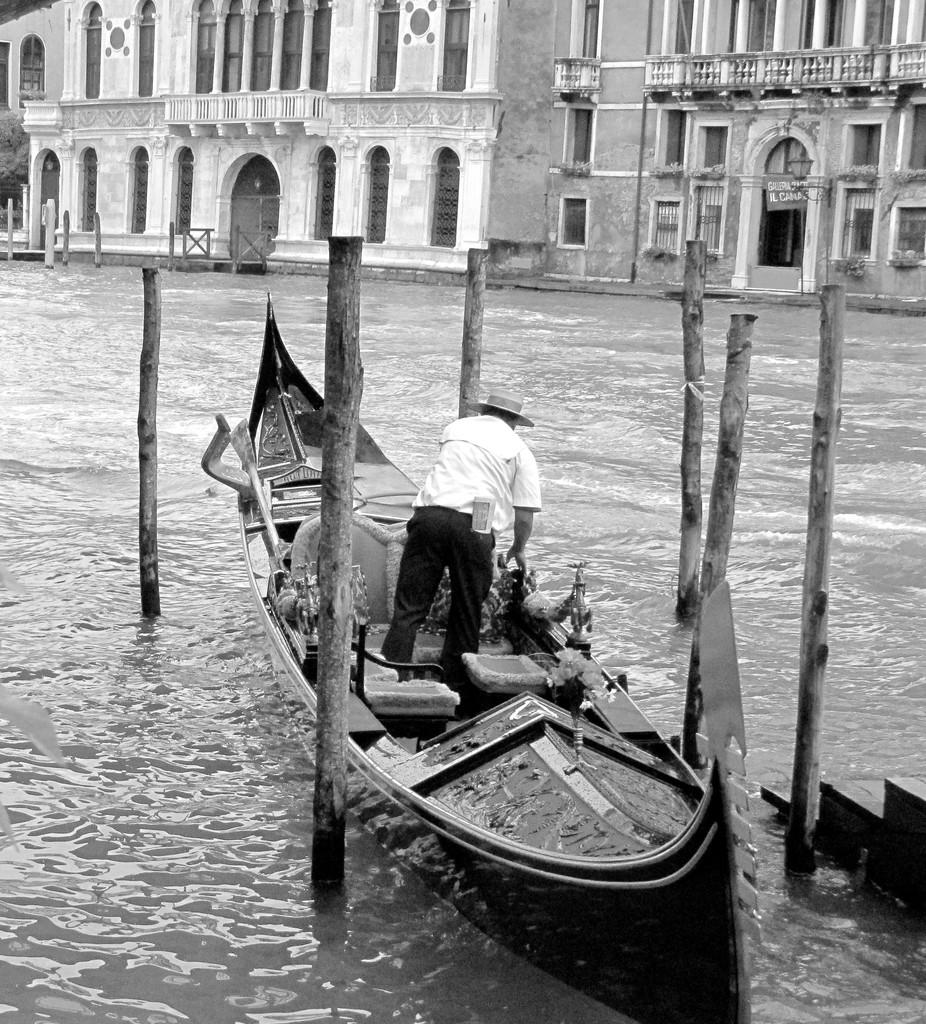What is the main subject of the image? The main subject of the image is a ship in the water. Who or what is inside the ship? There is a man in the ship. What type of furniture is present in the ship? There are wooden chairs in the ship. What can be seen in the distance behind the ship? There are buildings visible in the background. How many babies are crawling on the finger in the image? There is no finger or babies present in the image. 